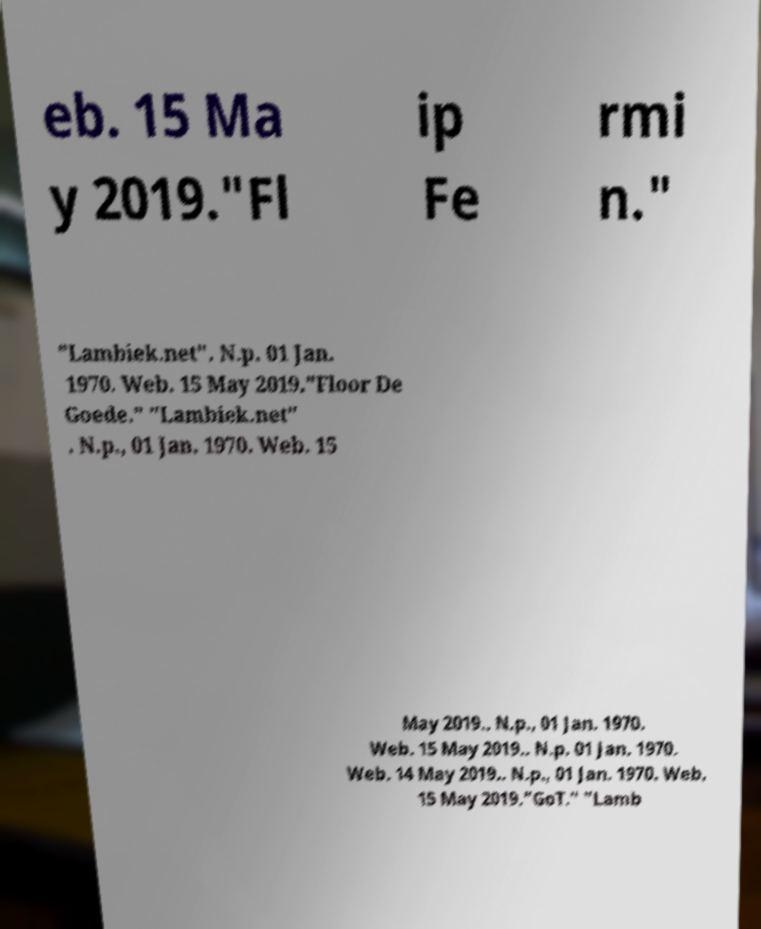What messages or text are displayed in this image? I need them in a readable, typed format. eb. 15 Ma y 2019."Fl ip Fe rmi n." "Lambiek.net". N.p. 01 Jan. 1970. Web. 15 May 2019."Floor De Goede." "Lambiek.net" . N.p., 01 Jan. 1970. Web. 15 May 2019.. N.p., 01 Jan. 1970. Web. 15 May 2019.. N.p. 01 Jan. 1970. Web. 14 May 2019.. N.p., 01 Jan. 1970. Web. 15 May 2019."GoT." "Lamb 